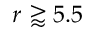<formula> <loc_0><loc_0><loc_500><loc_500>r \gtrapprox 5 . 5</formula> 